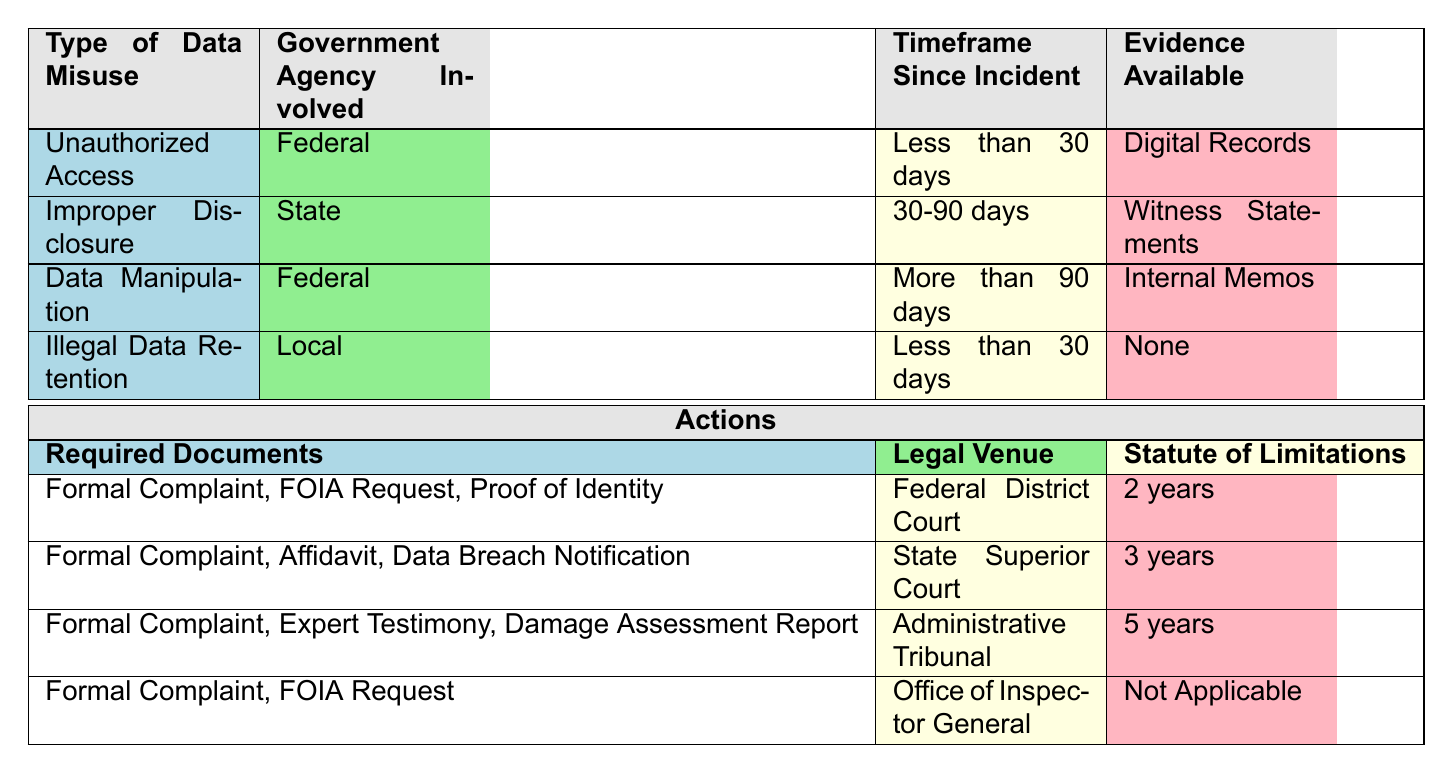What required documents are needed for cases of improper disclosure involving a state government agency within 30-90 days? From the table, for "Improper Disclosure," under "State" and "30-90 days," the required documents are listed as "Formal Complaint, Affidavit, Data Breach Notification."
Answer: Formal Complaint, Affidavit, Data Breach Notification Which legal venue should be used for unauthorized access cases with less than 30 days since the incident? The table indicates that for "Unauthorized Access" within "Less than 30 days," the legal venue is "Federal District Court."
Answer: Federal District Court Is a FOIA request required for illegal data retention cases involving a local agency? According to the table, for "Illegal Data Retention" involving a "Local" agency, the required documents include "Formal Complaint, FOIA Request." Therefore, the answer is yes, a FOIA request is required.
Answer: Yes What is the statute of limitations for data manipulation cases involving federal agencies after more than 90 days? From the table, for "Data Manipulation" involving "Federal" and "More than 90 days," the statute of limitations is "5 years."
Answer: 5 years Are digital records required as evidence for initiating legal action in cases of unauthorized access? The table specifies that for "Unauthorized Access," digital records are available as evidence, which implies it is indeed required.
Answer: Yes What is the total number of required documents for cases of illegal data retention with no evidence? For "Illegal Data Retention" where "Evidence Available" is "None," the required documents are "Formal Complaint, FOIA Request." Therefore, there are 2 documents needed.
Answer: 2 If someone wants to file a legal action for improper disclosure, which document is necessary in addition to a formal complaint? Based on the table for "Improper Disclosure" involving a "State" agency within "30-90 days," in addition to the formal complaint, an affidavit is also required.
Answer: Affidavit What are the required documents and legal venue for data manipulation cases lasting more than 90 days? For "Data Manipulation" involving "Federal" and "More than 90 days," the required documents are "Formal Complaint, Expert Testimony, Damage Assessment Report," and the legal venue is "Administrative Tribunal."
Answer: Formal Complaint, Expert Testimony, Damage Assessment Report; Administrative Tribunal 